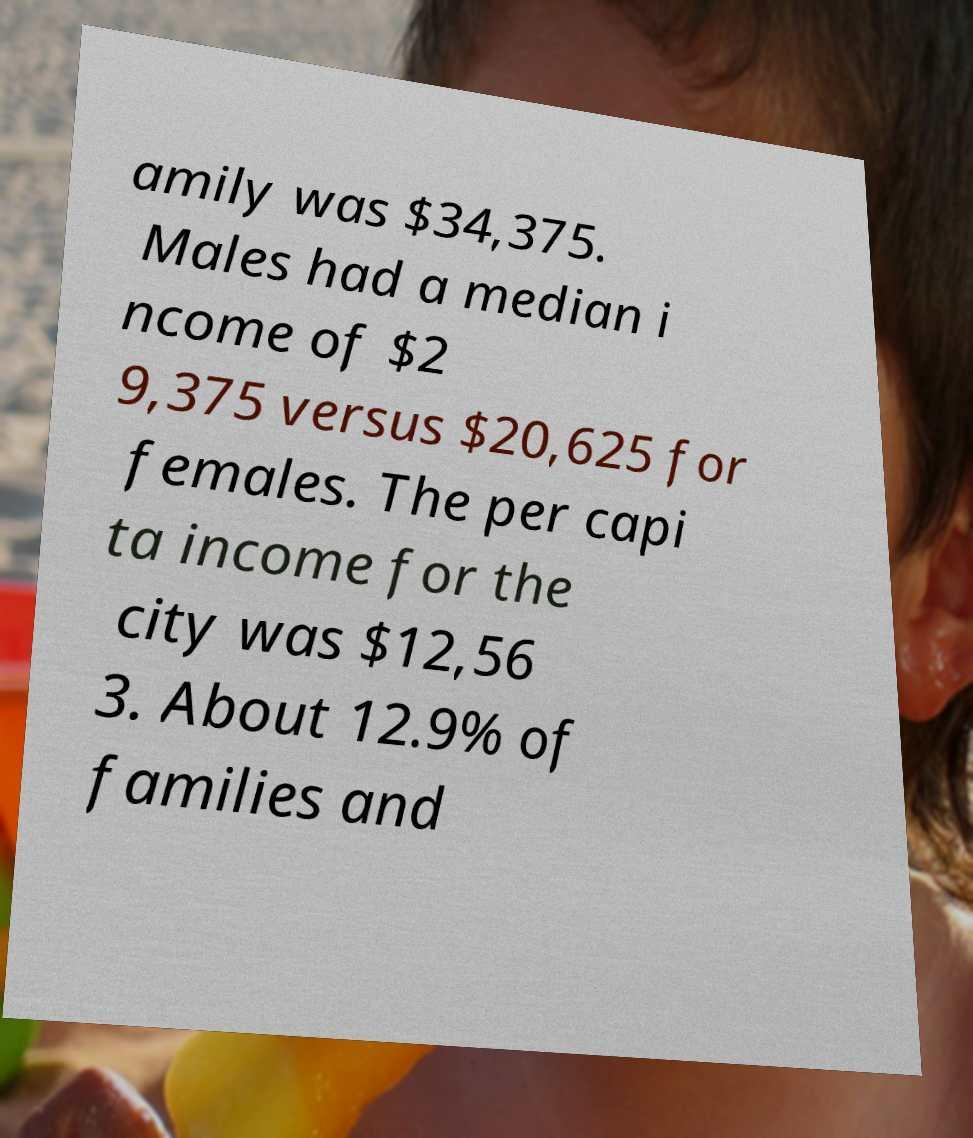Can you accurately transcribe the text from the provided image for me? amily was $34,375. Males had a median i ncome of $2 9,375 versus $20,625 for females. The per capi ta income for the city was $12,56 3. About 12.9% of families and 